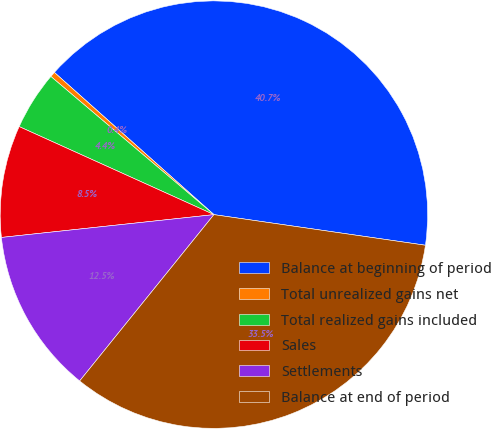<chart> <loc_0><loc_0><loc_500><loc_500><pie_chart><fcel>Balance at beginning of period<fcel>Total unrealized gains net<fcel>Total realized gains included<fcel>Sales<fcel>Settlements<fcel>Balance at end of period<nl><fcel>40.7%<fcel>0.4%<fcel>4.43%<fcel>8.46%<fcel>12.49%<fcel>33.52%<nl></chart> 